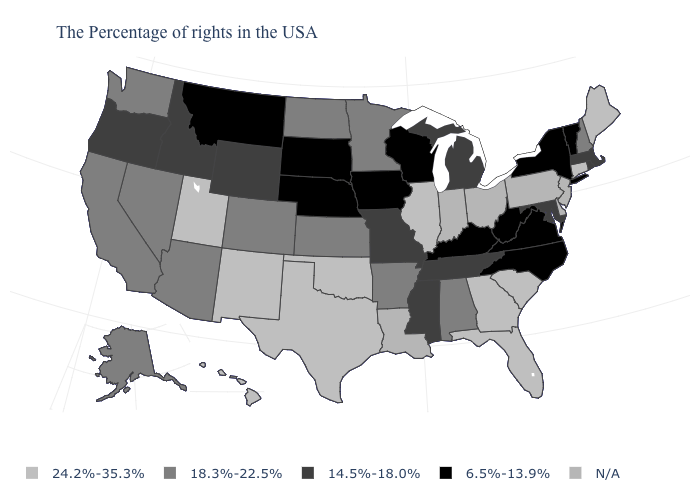Name the states that have a value in the range 14.5%-18.0%?
Concise answer only. Massachusetts, Rhode Island, Maryland, Michigan, Tennessee, Mississippi, Missouri, Wyoming, Idaho, Oregon. What is the value of Oklahoma?
Write a very short answer. 24.2%-35.3%. Which states have the lowest value in the MidWest?
Give a very brief answer. Wisconsin, Iowa, Nebraska, South Dakota. Among the states that border Maine , which have the highest value?
Short answer required. New Hampshire. Which states have the lowest value in the USA?
Keep it brief. Vermont, New York, Virginia, North Carolina, West Virginia, Kentucky, Wisconsin, Iowa, Nebraska, South Dakota, Montana. Name the states that have a value in the range 18.3%-22.5%?
Quick response, please. New Hampshire, Alabama, Arkansas, Minnesota, Kansas, North Dakota, Colorado, Arizona, Nevada, California, Washington, Alaska. What is the lowest value in states that border Pennsylvania?
Answer briefly. 6.5%-13.9%. What is the highest value in the USA?
Be succinct. 24.2%-35.3%. Does Massachusetts have the highest value in the Northeast?
Answer briefly. No. Does the map have missing data?
Be succinct. Yes. Does the map have missing data?
Give a very brief answer. Yes. What is the lowest value in states that border Michigan?
Concise answer only. 6.5%-13.9%. What is the highest value in the USA?
Write a very short answer. 24.2%-35.3%. 